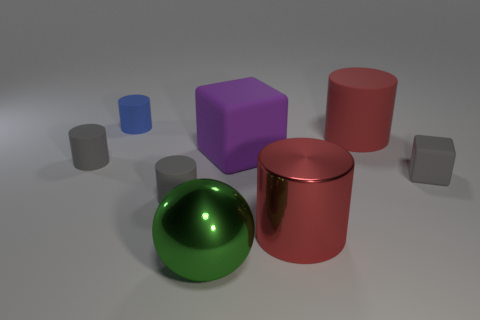Subtract all big matte cylinders. How many cylinders are left? 4 Add 1 big cyan matte blocks. How many objects exist? 9 Subtract all gray cubes. How many cubes are left? 1 Subtract 2 cylinders. How many cylinders are left? 3 Subtract all cyan cylinders. How many cyan cubes are left? 0 Subtract all gray things. Subtract all large red matte objects. How many objects are left? 4 Add 3 large matte cubes. How many large matte cubes are left? 4 Add 1 gray rubber objects. How many gray rubber objects exist? 4 Subtract 0 purple balls. How many objects are left? 8 Subtract all balls. How many objects are left? 7 